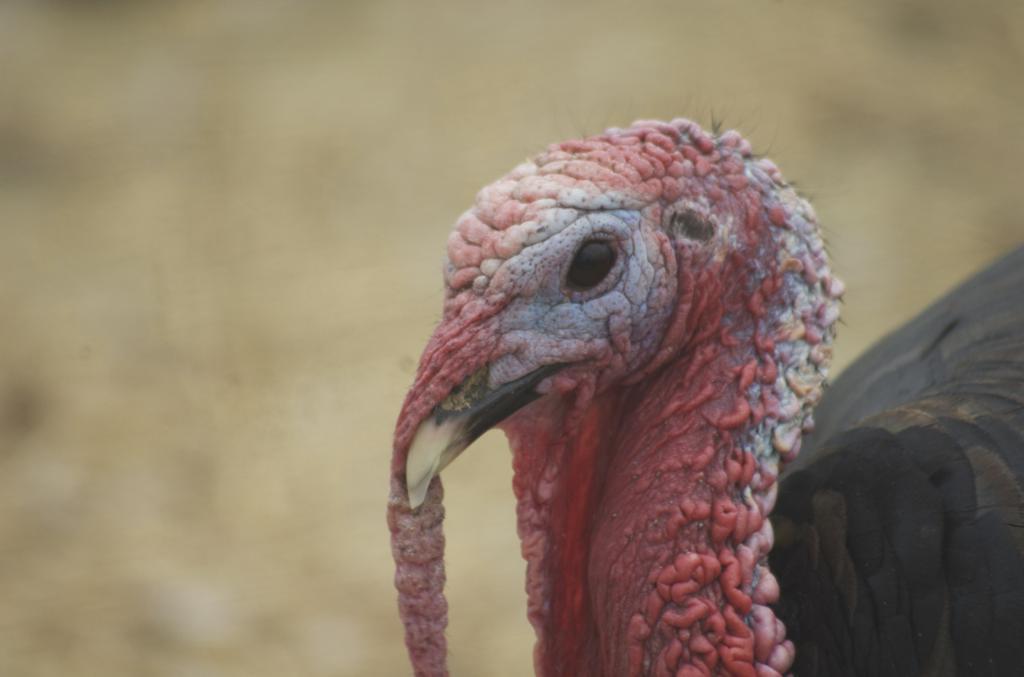Can you describe this image briefly? In this image I can see a bird which is black , brown, red and white in color. In the background I can see a cream colored blurred picture. 